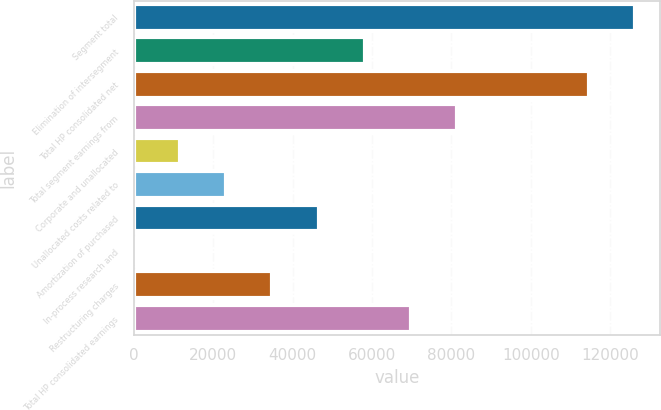Convert chart to OTSL. <chart><loc_0><loc_0><loc_500><loc_500><bar_chart><fcel>Segment total<fcel>Elimination of intersegment<fcel>Total HP consolidated net<fcel>Total segment earnings from<fcel>Corporate and unallocated<fcel>Unallocated costs related to<fcel>Amortization of purchased<fcel>In-process research and<fcel>Restructuring charges<fcel>Total HP consolidated earnings<nl><fcel>126189<fcel>58194<fcel>114552<fcel>81468.8<fcel>11644.4<fcel>23281.8<fcel>46556.6<fcel>7<fcel>34919.2<fcel>69831.4<nl></chart> 